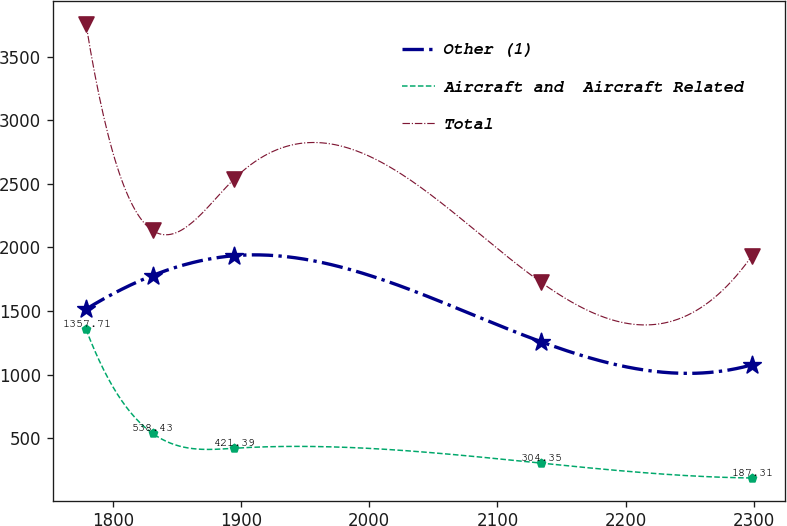<chart> <loc_0><loc_0><loc_500><loc_500><line_chart><ecel><fcel>Other (1)<fcel>Aircraft and  Aircraft Related<fcel>Total<nl><fcel>1778.91<fcel>1514.43<fcel>1357.71<fcel>3759.4<nl><fcel>1830.85<fcel>1779.43<fcel>538.43<fcel>2133.6<nl><fcel>1894.79<fcel>1935.51<fcel>421.39<fcel>2540.9<nl><fcel>2133.91<fcel>1259.32<fcel>304.35<fcel>1727.16<nl><fcel>2298.35<fcel>1076.42<fcel>187.31<fcel>1930.38<nl></chart> 